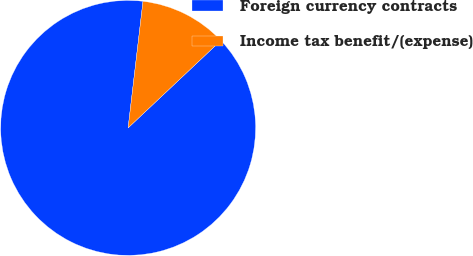<chart> <loc_0><loc_0><loc_500><loc_500><pie_chart><fcel>Foreign currency contracts<fcel>Income tax benefit/(expense)<nl><fcel>88.89%<fcel>11.11%<nl></chart> 